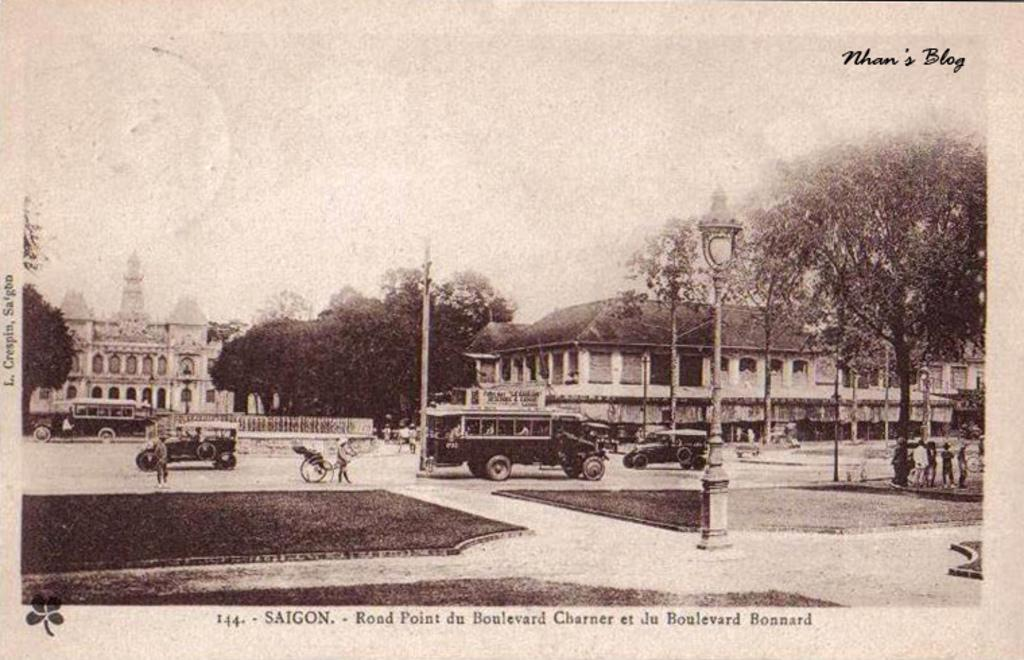<image>
Describe the image concisely. An old photo says Saigon and shows a city and old vehicles. 